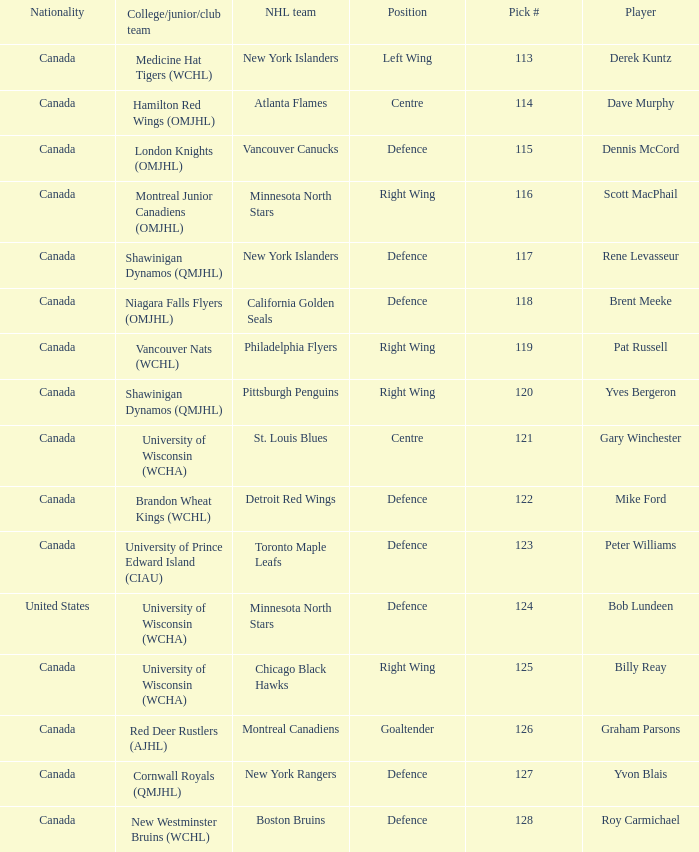Name the player for chicago black hawks Billy Reay. 